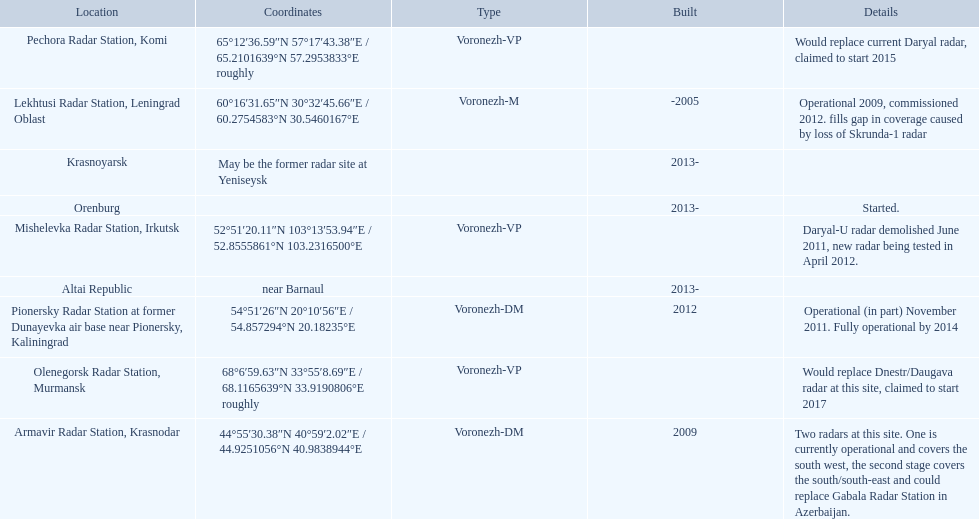Where is each radar? Lekhtusi Radar Station, Leningrad Oblast, Armavir Radar Station, Krasnodar, Pionersky Radar Station at former Dunayevka air base near Pionersky, Kaliningrad, Mishelevka Radar Station, Irkutsk, Pechora Radar Station, Komi, Olenegorsk Radar Station, Murmansk, Krasnoyarsk, Altai Republic, Orenburg. What are the details of each radar? Operational 2009, commissioned 2012. fills gap in coverage caused by loss of Skrunda-1 radar, Two radars at this site. One is currently operational and covers the south west, the second stage covers the south/south-east and could replace Gabala Radar Station in Azerbaijan., Operational (in part) November 2011. Fully operational by 2014, Daryal-U radar demolished June 2011, new radar being tested in April 2012., Would replace current Daryal radar, claimed to start 2015, Would replace Dnestr/Daugava radar at this site, claimed to start 2017, , , Started. Which radar is detailed to start in 2015? Pechora Radar Station, Komi. 